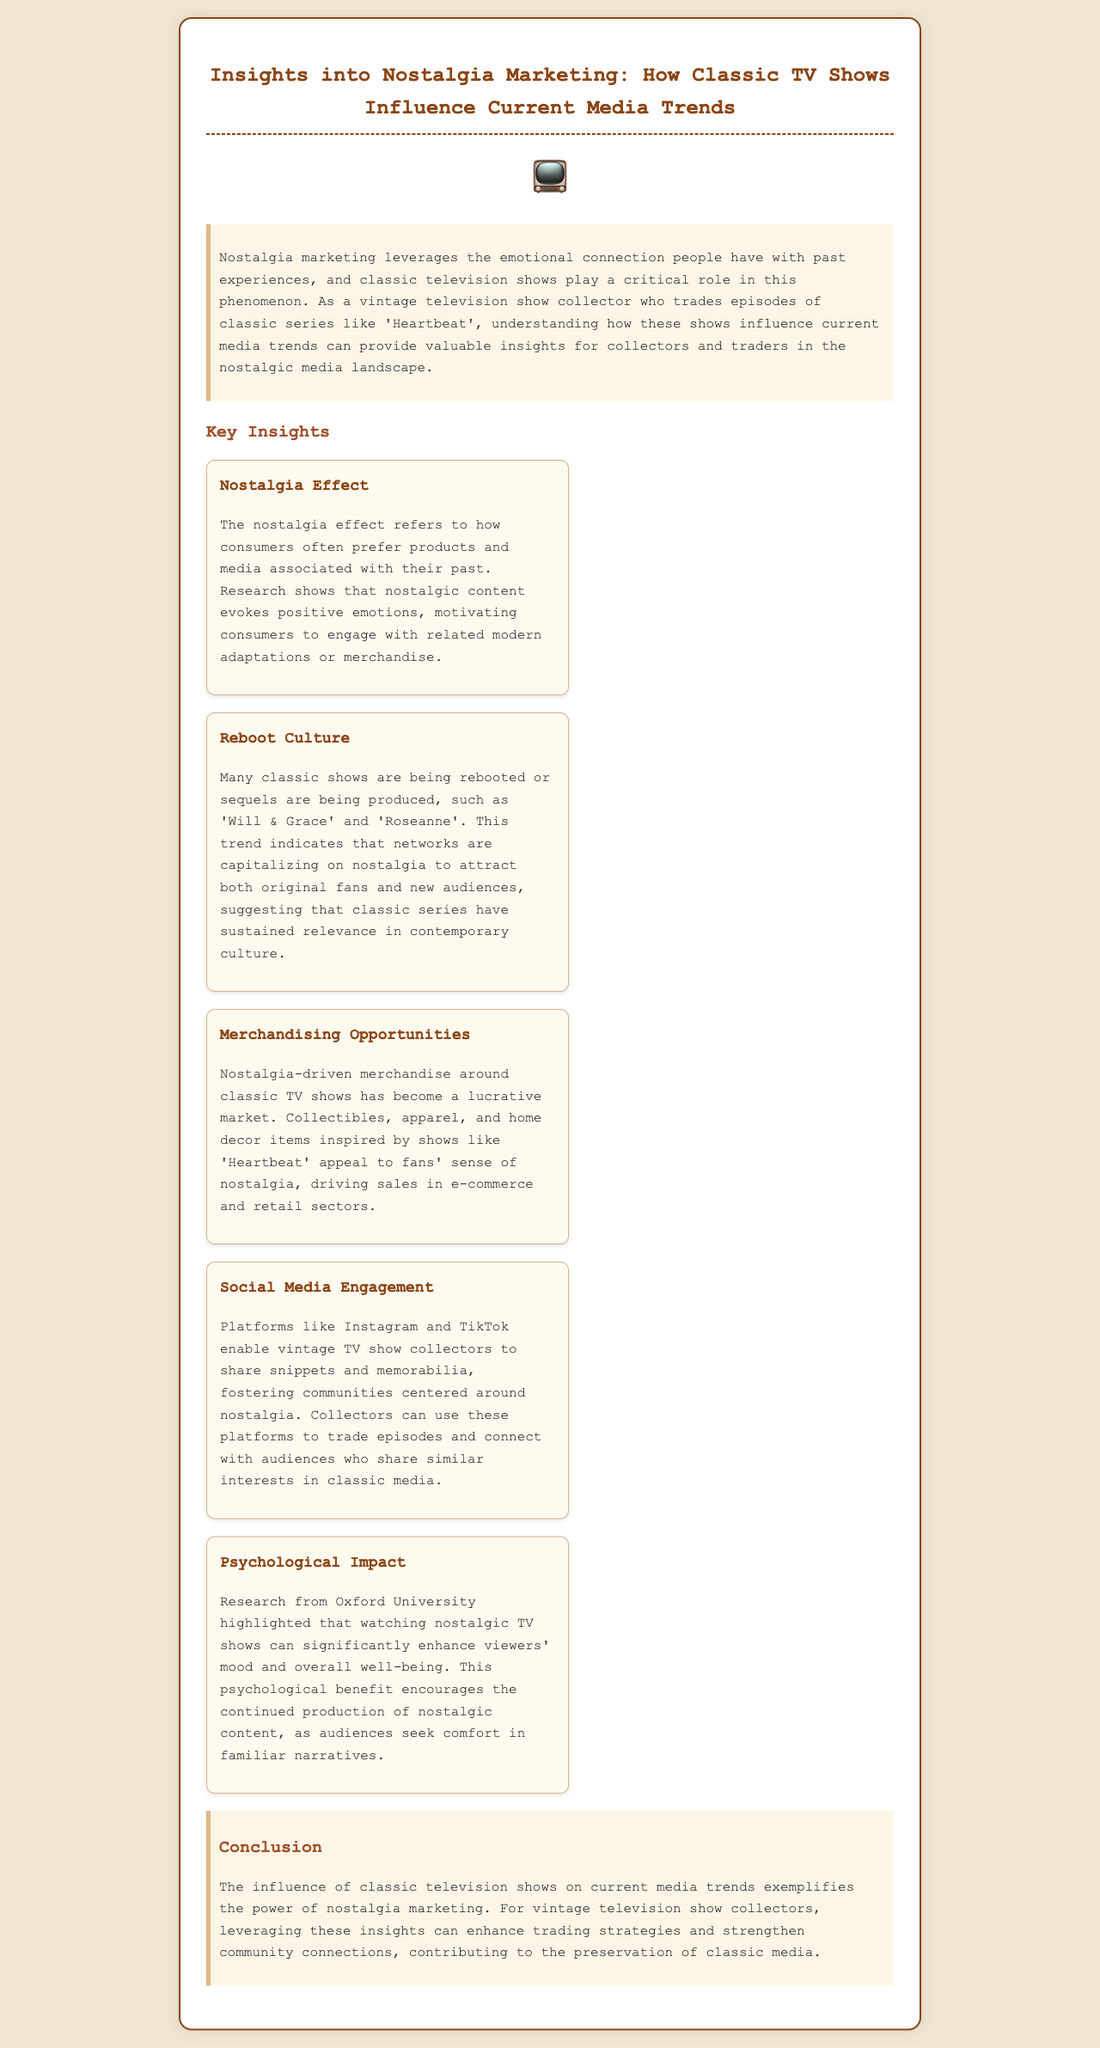What is the title of the report? The title is prominently displayed at the top of the document, which is "Insights into Nostalgia Marketing: How Classic TV Shows Influence Current Media Trends."
Answer: Insights into Nostalgia Marketing: How Classic TV Shows Influence Current Media Trends Which classic TV show is mentioned as an example in merchandising opportunities? The document mentions 'Heartbeat' as a classic TV show that has inspired nostalgia-driven merchandise.
Answer: Heartbeat What psychological benefit is highlighted in the document regarding nostalgic TV shows? The document states that watching nostalgic TV shows can significantly enhance viewers' mood and overall well-being.
Answer: Enhance viewers' mood Which platforms are identified for social media engagement among collectors? The document specifically mentions Instagram and TikTok as platforms for vintage TV show collectors.
Answer: Instagram and TikTok What trend is indicated by the mention of 'Will & Grace' and 'Roseanne'? The mention of these shows indicates the trend of reboot culture in television.
Answer: Reboot culture How does the document describe the emotional impact of nostalgic content? It describes that nostalgic content evokes positive emotions, motivating consumer engagement.
Answer: Evokes positive emotions What is the primary emotional connection that nostalgia marketing leverages? Nostalgia marketing leverages the emotional connection people have with past experiences.
Answer: Past experiences 